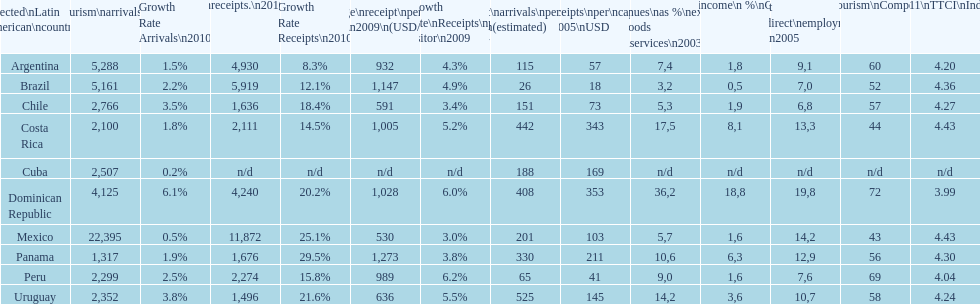In which country do most categories have the best rankings? Dominican Republic. 